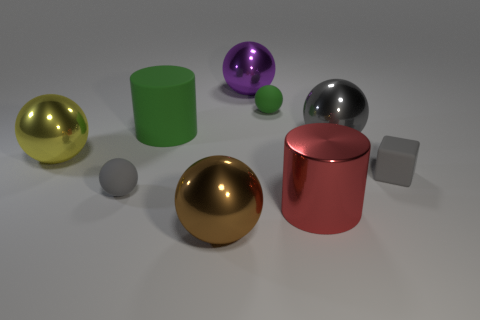Are there any objects in this image that have textures, patterns, or any kind of detailing? The objects in this image are all rendered with smooth finishes and do not display any textures, patterns, or detailed embellishments. They have a minimalist design with a focus on solid colors and reflective surfaces. 